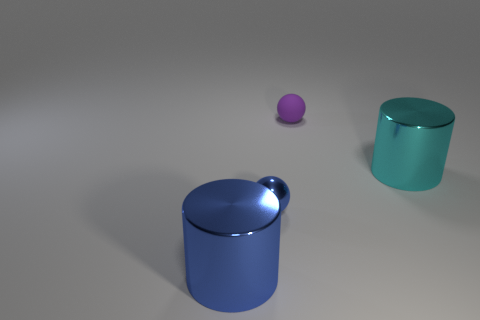How many other things are the same color as the tiny shiny ball?
Keep it short and to the point. 1. There is a small metal ball; what number of small blue metallic spheres are on the left side of it?
Keep it short and to the point. 0. There is another object that is the same shape as the small blue object; what is its size?
Make the answer very short. Small. What number of yellow things are small shiny balls or small matte objects?
Provide a short and direct response. 0. There is a big blue metal object in front of the cyan metal cylinder; what number of metal objects are on the left side of it?
Provide a short and direct response. 0. How many other objects are the same shape as the tiny rubber thing?
Make the answer very short. 1. What material is the large thing that is the same color as the shiny sphere?
Provide a short and direct response. Metal. What number of big cylinders have the same color as the tiny shiny object?
Give a very brief answer. 1. What is the color of the cylinder that is the same material as the large cyan thing?
Your answer should be compact. Blue. Is there a purple rubber sphere that has the same size as the blue metal sphere?
Your response must be concise. Yes. 